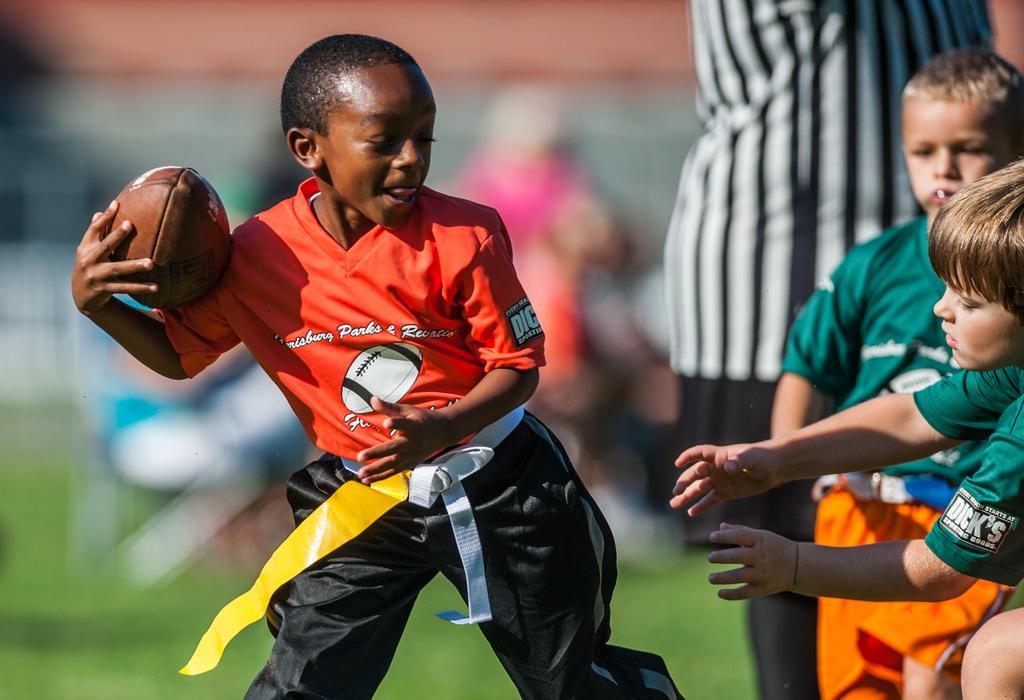Can you describe this image briefly? In this image there are the children playing a game and a boy wearing a red color holding a ball on his hand. 